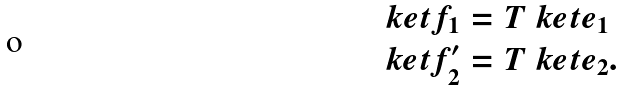<formula> <loc_0><loc_0><loc_500><loc_500>\ k e t { f _ { 1 } } & = T \ k e t { e _ { 1 } } \\ \ k e t { f ^ { \prime } _ { 2 } } & = T \ k e t { e _ { 2 } } .</formula> 